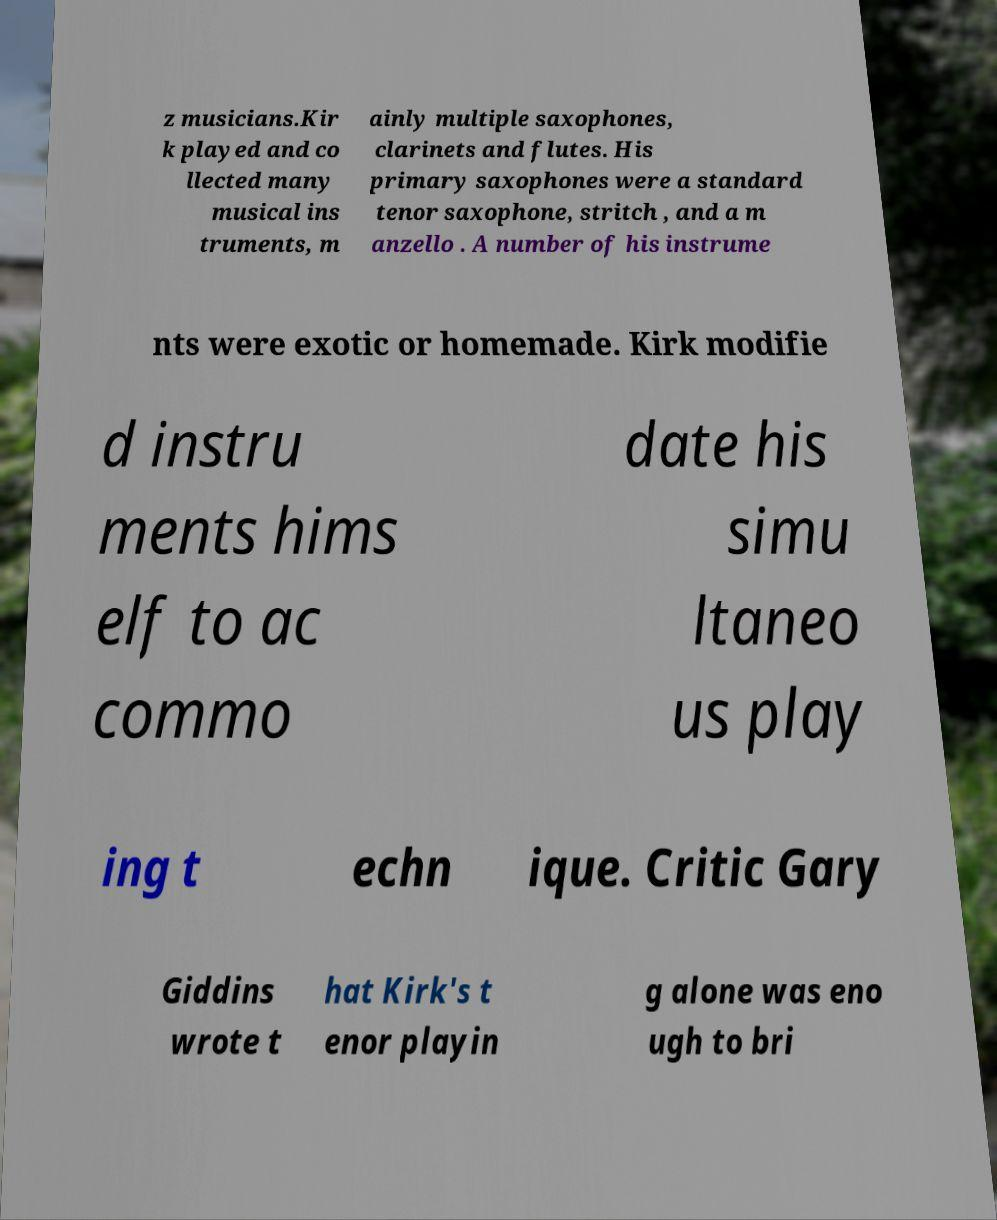I need the written content from this picture converted into text. Can you do that? z musicians.Kir k played and co llected many musical ins truments, m ainly multiple saxophones, clarinets and flutes. His primary saxophones were a standard tenor saxophone, stritch , and a m anzello . A number of his instrume nts were exotic or homemade. Kirk modifie d instru ments hims elf to ac commo date his simu ltaneo us play ing t echn ique. Critic Gary Giddins wrote t hat Kirk's t enor playin g alone was eno ugh to bri 